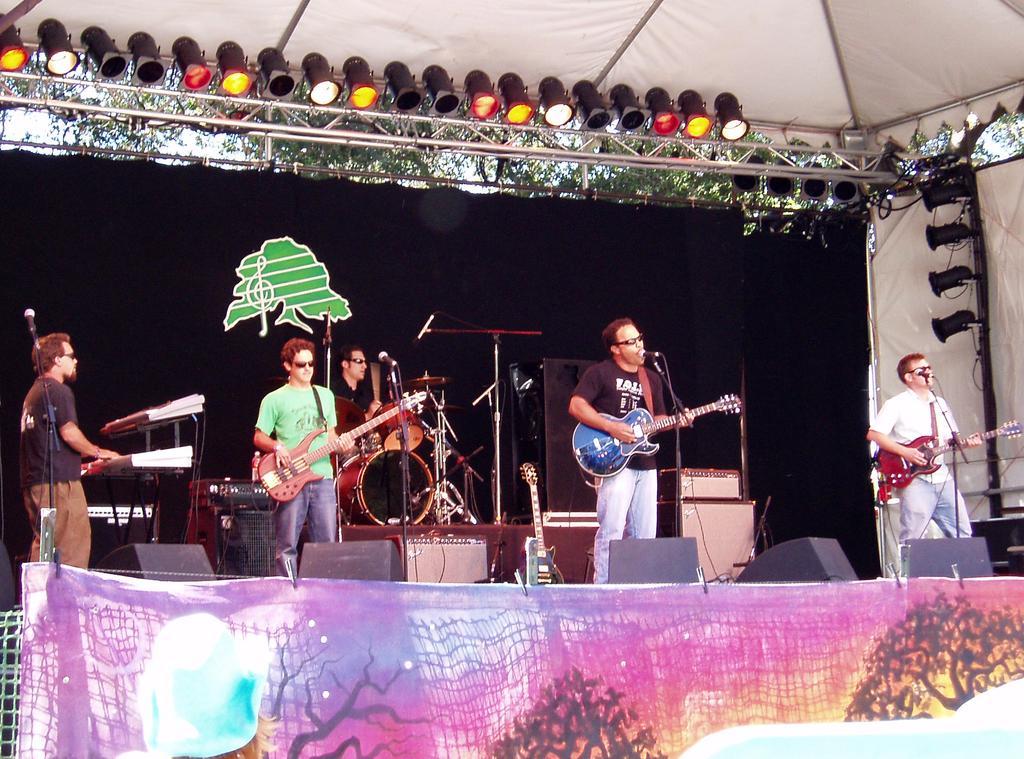How would you summarize this image in a sentence or two? In this image in a stage people are playing musical instruments. Some of them are playing guitar. One person on left is playing keyboard. Behind one person is playing drums. There are mics in front of them. On the top there are lights. There is a black background. There is a banner here. 